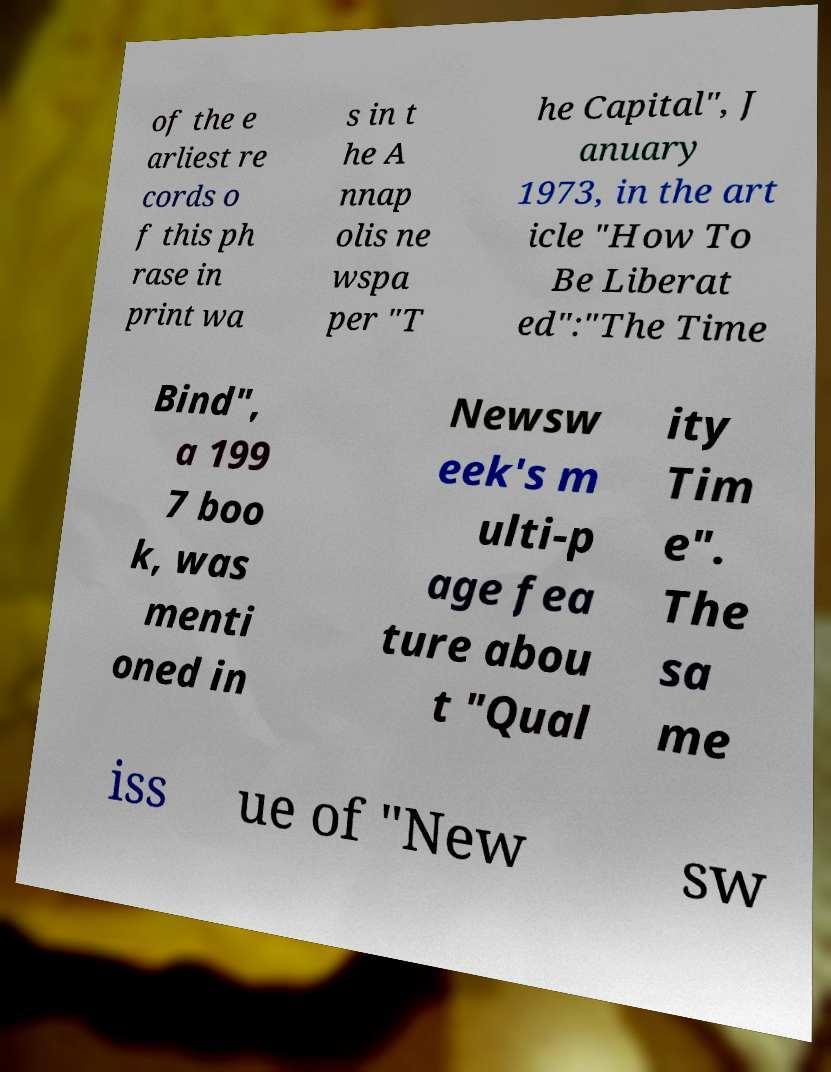What messages or text are displayed in this image? I need them in a readable, typed format. of the e arliest re cords o f this ph rase in print wa s in t he A nnap olis ne wspa per "T he Capital", J anuary 1973, in the art icle "How To Be Liberat ed":"The Time Bind", a 199 7 boo k, was menti oned in Newsw eek's m ulti-p age fea ture abou t "Qual ity Tim e". The sa me iss ue of "New sw 